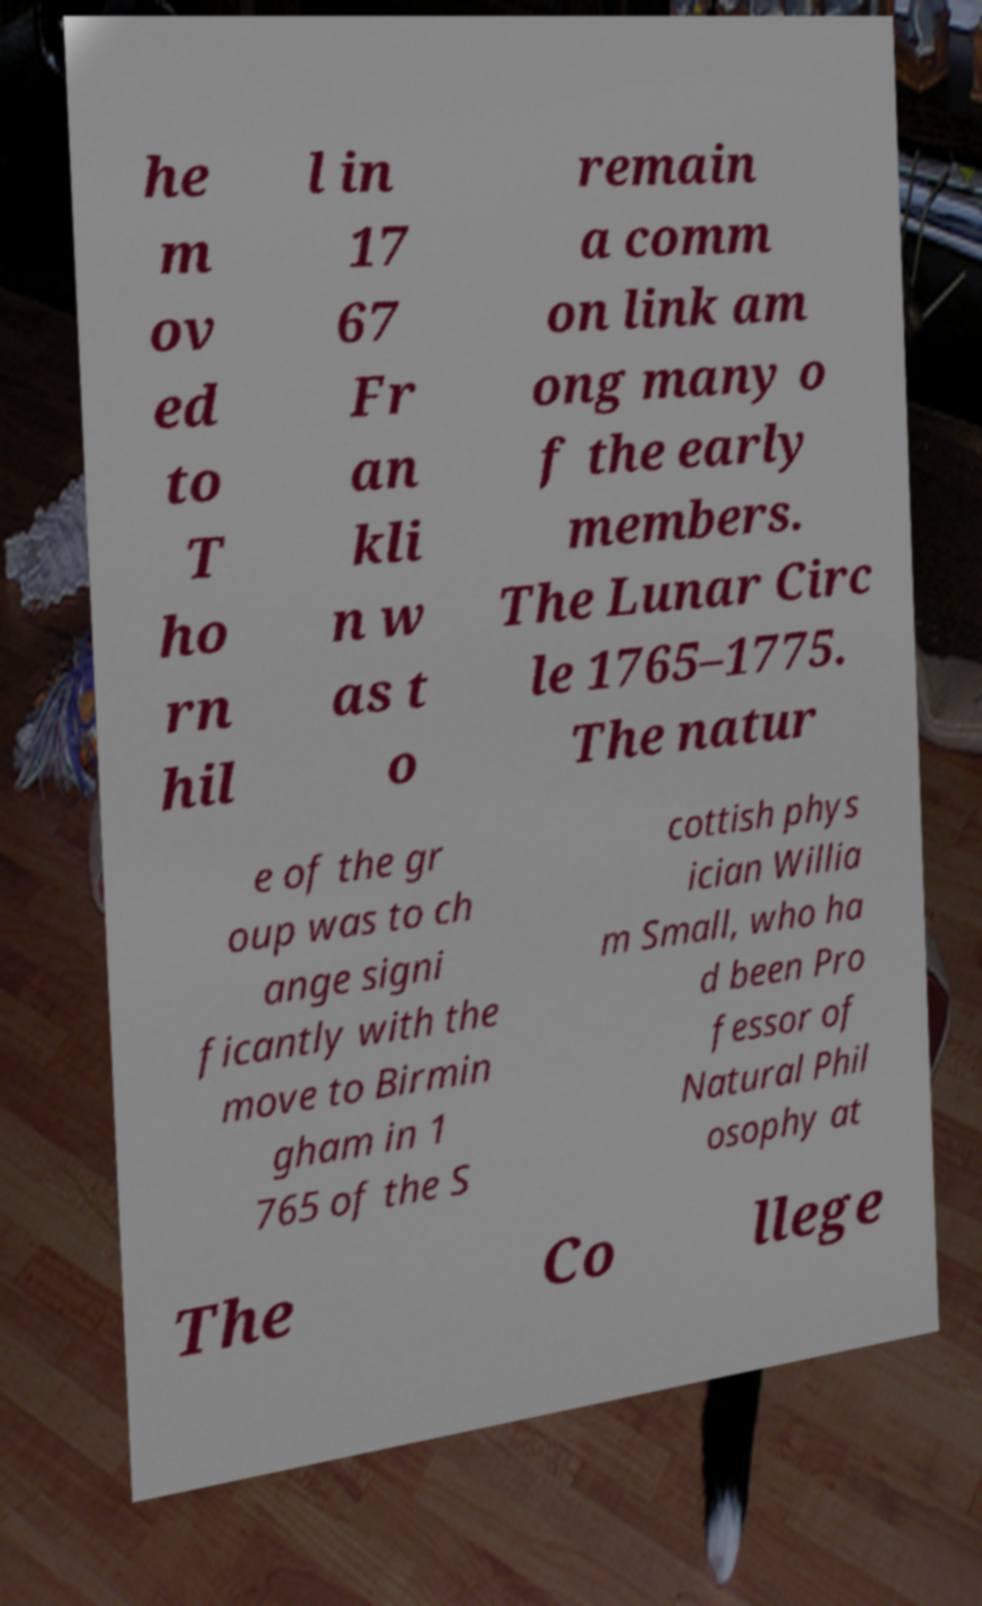What messages or text are displayed in this image? I need them in a readable, typed format. he m ov ed to T ho rn hil l in 17 67 Fr an kli n w as t o remain a comm on link am ong many o f the early members. The Lunar Circ le 1765–1775. The natur e of the gr oup was to ch ange signi ficantly with the move to Birmin gham in 1 765 of the S cottish phys ician Willia m Small, who ha d been Pro fessor of Natural Phil osophy at The Co llege 